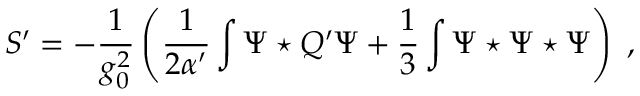Convert formula to latex. <formula><loc_0><loc_0><loc_500><loc_500>S ^ { \prime } = - \frac { 1 } { g _ { 0 } ^ { 2 } } \left ( \frac { 1 } { 2 \alpha ^ { \prime } } \int \Psi ^ { * } Q ^ { \prime } \Psi + \frac { 1 } { 3 } \int \Psi ^ { * } \Psi ^ { * } \Psi \right ) \ ,</formula> 